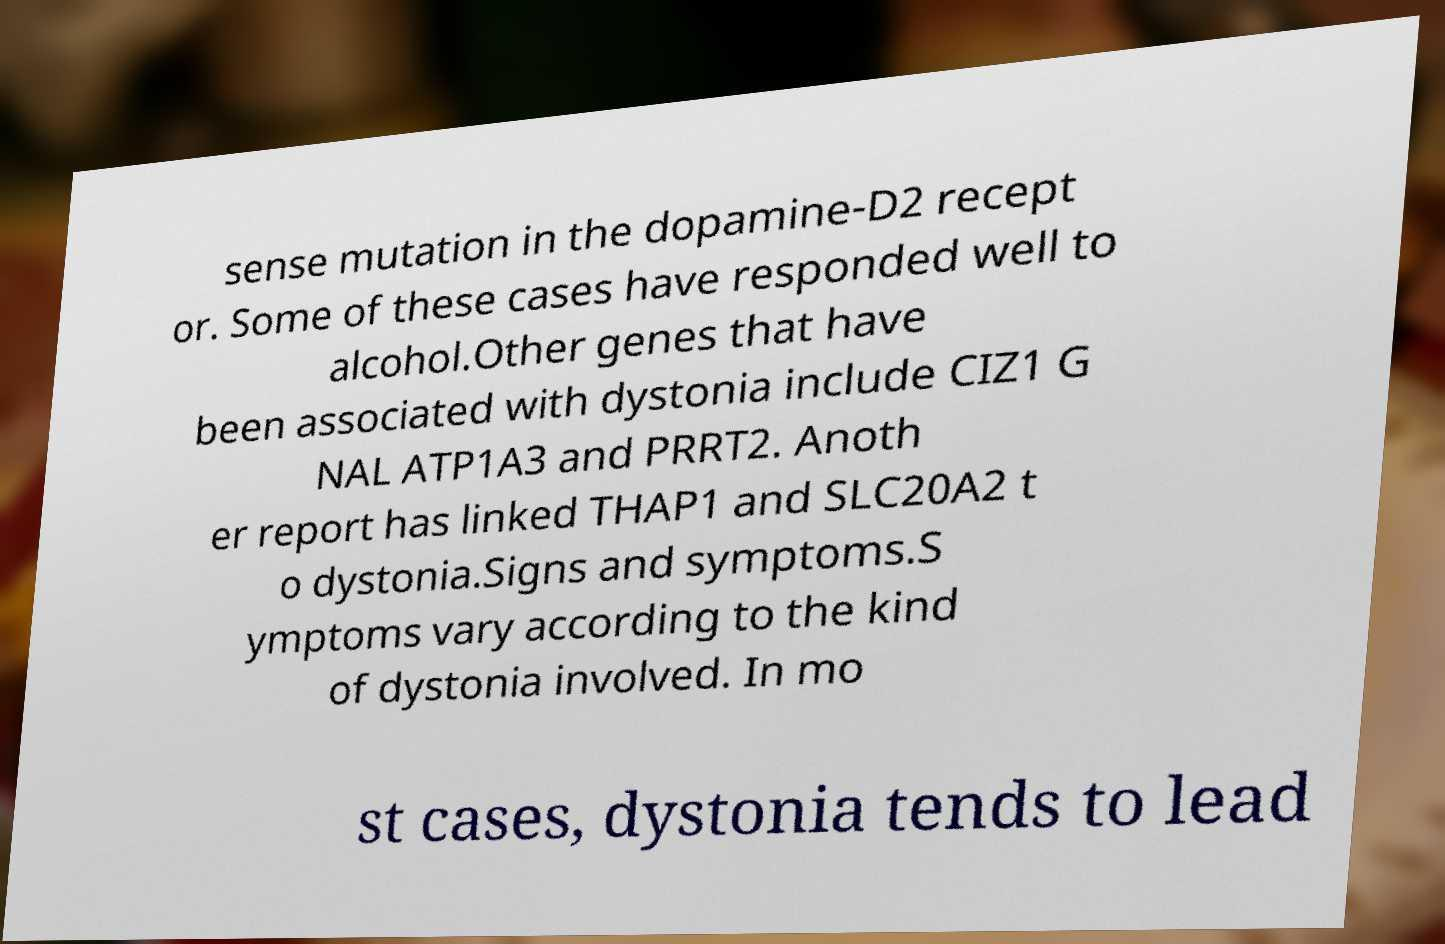Could you extract and type out the text from this image? sense mutation in the dopamine-D2 recept or. Some of these cases have responded well to alcohol.Other genes that have been associated with dystonia include CIZ1 G NAL ATP1A3 and PRRT2. Anoth er report has linked THAP1 and SLC20A2 t o dystonia.Signs and symptoms.S ymptoms vary according to the kind of dystonia involved. In mo st cases, dystonia tends to lead 